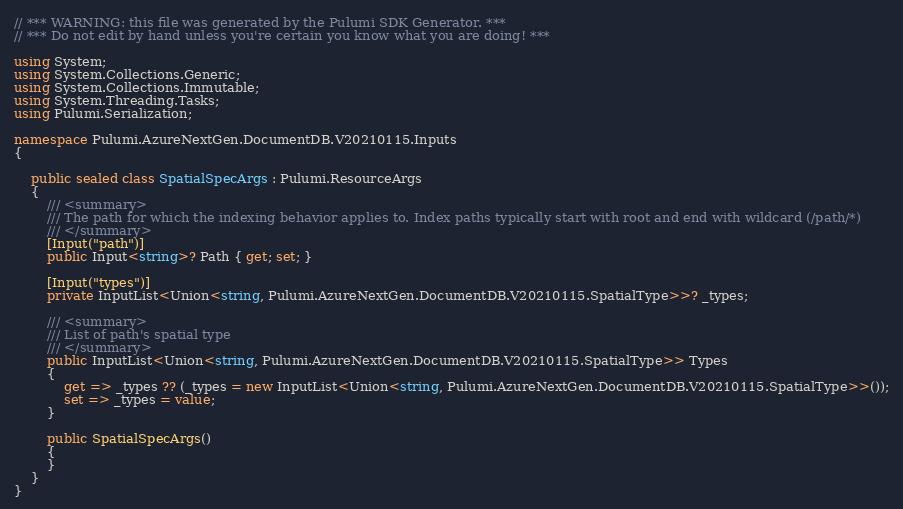<code> <loc_0><loc_0><loc_500><loc_500><_C#_>// *** WARNING: this file was generated by the Pulumi SDK Generator. ***
// *** Do not edit by hand unless you're certain you know what you are doing! ***

using System;
using System.Collections.Generic;
using System.Collections.Immutable;
using System.Threading.Tasks;
using Pulumi.Serialization;

namespace Pulumi.AzureNextGen.DocumentDB.V20210115.Inputs
{

    public sealed class SpatialSpecArgs : Pulumi.ResourceArgs
    {
        /// <summary>
        /// The path for which the indexing behavior applies to. Index paths typically start with root and end with wildcard (/path/*)
        /// </summary>
        [Input("path")]
        public Input<string>? Path { get; set; }

        [Input("types")]
        private InputList<Union<string, Pulumi.AzureNextGen.DocumentDB.V20210115.SpatialType>>? _types;

        /// <summary>
        /// List of path's spatial type
        /// </summary>
        public InputList<Union<string, Pulumi.AzureNextGen.DocumentDB.V20210115.SpatialType>> Types
        {
            get => _types ?? (_types = new InputList<Union<string, Pulumi.AzureNextGen.DocumentDB.V20210115.SpatialType>>());
            set => _types = value;
        }

        public SpatialSpecArgs()
        {
        }
    }
}
</code> 